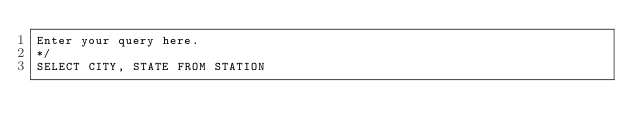Convert code to text. <code><loc_0><loc_0><loc_500><loc_500><_SQL_>Enter your query here.
*/
SELECT CITY, STATE FROM STATION</code> 